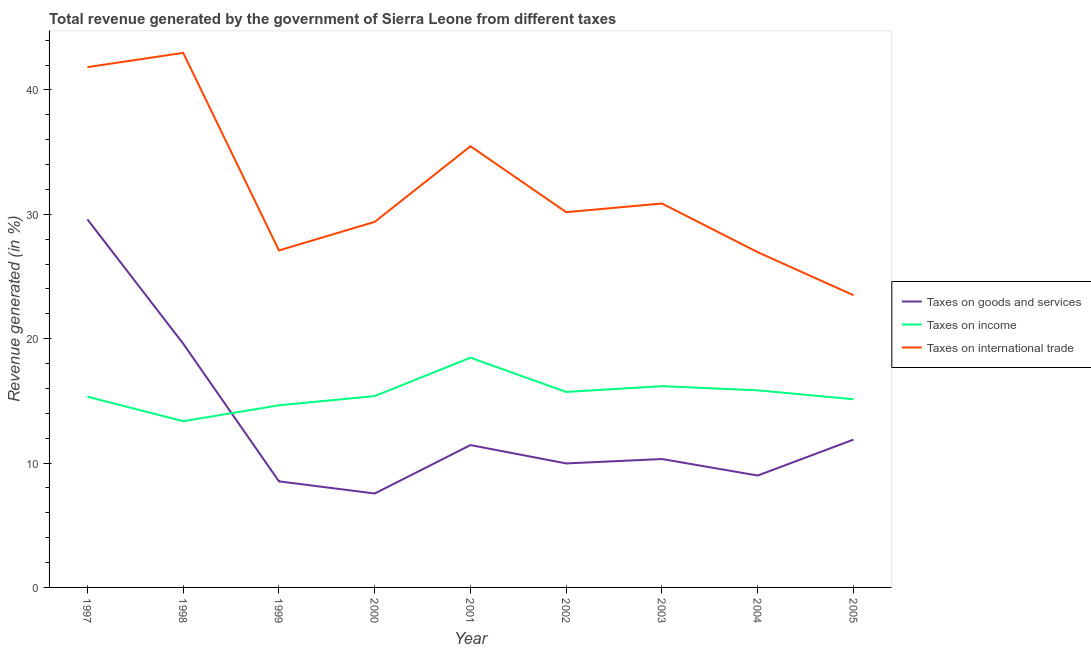Is the number of lines equal to the number of legend labels?
Keep it short and to the point. Yes. What is the percentage of revenue generated by tax on international trade in 2004?
Ensure brevity in your answer.  26.96. Across all years, what is the maximum percentage of revenue generated by taxes on goods and services?
Provide a short and direct response. 29.59. Across all years, what is the minimum percentage of revenue generated by taxes on income?
Offer a very short reply. 13.37. In which year was the percentage of revenue generated by tax on international trade maximum?
Provide a short and direct response. 1998. What is the total percentage of revenue generated by tax on international trade in the graph?
Offer a terse response. 288.28. What is the difference between the percentage of revenue generated by tax on international trade in 2000 and that in 2001?
Provide a succinct answer. -6.08. What is the difference between the percentage of revenue generated by taxes on income in 1997 and the percentage of revenue generated by tax on international trade in 2000?
Provide a short and direct response. -14.06. What is the average percentage of revenue generated by tax on international trade per year?
Keep it short and to the point. 32.03. In the year 2003, what is the difference between the percentage of revenue generated by tax on international trade and percentage of revenue generated by taxes on goods and services?
Provide a succinct answer. 20.55. What is the ratio of the percentage of revenue generated by taxes on goods and services in 2000 to that in 2003?
Provide a short and direct response. 0.73. What is the difference between the highest and the second highest percentage of revenue generated by tax on international trade?
Provide a succinct answer. 1.15. What is the difference between the highest and the lowest percentage of revenue generated by taxes on income?
Provide a short and direct response. 5.1. In how many years, is the percentage of revenue generated by taxes on goods and services greater than the average percentage of revenue generated by taxes on goods and services taken over all years?
Your answer should be compact. 2. Is the percentage of revenue generated by taxes on goods and services strictly less than the percentage of revenue generated by tax on international trade over the years?
Your response must be concise. Yes. How many lines are there?
Your answer should be compact. 3. How many years are there in the graph?
Your response must be concise. 9. Does the graph contain any zero values?
Keep it short and to the point. No. Where does the legend appear in the graph?
Ensure brevity in your answer.  Center right. What is the title of the graph?
Keep it short and to the point. Total revenue generated by the government of Sierra Leone from different taxes. Does "Ages 15-20" appear as one of the legend labels in the graph?
Provide a succinct answer. No. What is the label or title of the Y-axis?
Keep it short and to the point. Revenue generated (in %). What is the Revenue generated (in %) of Taxes on goods and services in 1997?
Your answer should be very brief. 29.59. What is the Revenue generated (in %) in Taxes on income in 1997?
Give a very brief answer. 15.34. What is the Revenue generated (in %) of Taxes on international trade in 1997?
Give a very brief answer. 41.84. What is the Revenue generated (in %) in Taxes on goods and services in 1998?
Provide a succinct answer. 19.6. What is the Revenue generated (in %) of Taxes on income in 1998?
Provide a succinct answer. 13.37. What is the Revenue generated (in %) in Taxes on international trade in 1998?
Provide a short and direct response. 42.99. What is the Revenue generated (in %) in Taxes on goods and services in 1999?
Provide a short and direct response. 8.53. What is the Revenue generated (in %) of Taxes on income in 1999?
Your answer should be compact. 14.65. What is the Revenue generated (in %) of Taxes on international trade in 1999?
Keep it short and to the point. 27.1. What is the Revenue generated (in %) in Taxes on goods and services in 2000?
Offer a very short reply. 7.55. What is the Revenue generated (in %) in Taxes on income in 2000?
Your response must be concise. 15.39. What is the Revenue generated (in %) in Taxes on international trade in 2000?
Give a very brief answer. 29.39. What is the Revenue generated (in %) in Taxes on goods and services in 2001?
Make the answer very short. 11.45. What is the Revenue generated (in %) in Taxes on income in 2001?
Your response must be concise. 18.47. What is the Revenue generated (in %) of Taxes on international trade in 2001?
Offer a terse response. 35.48. What is the Revenue generated (in %) of Taxes on goods and services in 2002?
Make the answer very short. 9.97. What is the Revenue generated (in %) in Taxes on income in 2002?
Offer a terse response. 15.72. What is the Revenue generated (in %) in Taxes on international trade in 2002?
Give a very brief answer. 30.17. What is the Revenue generated (in %) of Taxes on goods and services in 2003?
Keep it short and to the point. 10.32. What is the Revenue generated (in %) in Taxes on income in 2003?
Offer a terse response. 16.18. What is the Revenue generated (in %) in Taxes on international trade in 2003?
Offer a very short reply. 30.87. What is the Revenue generated (in %) of Taxes on goods and services in 2004?
Provide a short and direct response. 9. What is the Revenue generated (in %) of Taxes on income in 2004?
Your response must be concise. 15.85. What is the Revenue generated (in %) of Taxes on international trade in 2004?
Your response must be concise. 26.96. What is the Revenue generated (in %) in Taxes on goods and services in 2005?
Offer a terse response. 11.89. What is the Revenue generated (in %) in Taxes on income in 2005?
Give a very brief answer. 15.13. What is the Revenue generated (in %) of Taxes on international trade in 2005?
Offer a very short reply. 23.5. Across all years, what is the maximum Revenue generated (in %) in Taxes on goods and services?
Make the answer very short. 29.59. Across all years, what is the maximum Revenue generated (in %) of Taxes on income?
Your response must be concise. 18.47. Across all years, what is the maximum Revenue generated (in %) in Taxes on international trade?
Your answer should be compact. 42.99. Across all years, what is the minimum Revenue generated (in %) in Taxes on goods and services?
Ensure brevity in your answer.  7.55. Across all years, what is the minimum Revenue generated (in %) of Taxes on income?
Provide a succinct answer. 13.37. Across all years, what is the minimum Revenue generated (in %) in Taxes on international trade?
Make the answer very short. 23.5. What is the total Revenue generated (in %) in Taxes on goods and services in the graph?
Provide a succinct answer. 117.9. What is the total Revenue generated (in %) in Taxes on income in the graph?
Your answer should be very brief. 140.09. What is the total Revenue generated (in %) of Taxes on international trade in the graph?
Offer a terse response. 288.28. What is the difference between the Revenue generated (in %) of Taxes on goods and services in 1997 and that in 1998?
Your answer should be very brief. 9.99. What is the difference between the Revenue generated (in %) of Taxes on income in 1997 and that in 1998?
Offer a terse response. 1.97. What is the difference between the Revenue generated (in %) of Taxes on international trade in 1997 and that in 1998?
Provide a succinct answer. -1.15. What is the difference between the Revenue generated (in %) in Taxes on goods and services in 1997 and that in 1999?
Give a very brief answer. 21.07. What is the difference between the Revenue generated (in %) in Taxes on income in 1997 and that in 1999?
Provide a short and direct response. 0.69. What is the difference between the Revenue generated (in %) in Taxes on international trade in 1997 and that in 1999?
Your answer should be compact. 14.74. What is the difference between the Revenue generated (in %) in Taxes on goods and services in 1997 and that in 2000?
Make the answer very short. 22.04. What is the difference between the Revenue generated (in %) in Taxes on income in 1997 and that in 2000?
Your answer should be very brief. -0.05. What is the difference between the Revenue generated (in %) of Taxes on international trade in 1997 and that in 2000?
Offer a terse response. 12.44. What is the difference between the Revenue generated (in %) in Taxes on goods and services in 1997 and that in 2001?
Offer a very short reply. 18.15. What is the difference between the Revenue generated (in %) in Taxes on income in 1997 and that in 2001?
Your answer should be very brief. -3.13. What is the difference between the Revenue generated (in %) of Taxes on international trade in 1997 and that in 2001?
Keep it short and to the point. 6.36. What is the difference between the Revenue generated (in %) of Taxes on goods and services in 1997 and that in 2002?
Provide a succinct answer. 19.62. What is the difference between the Revenue generated (in %) in Taxes on income in 1997 and that in 2002?
Your response must be concise. -0.38. What is the difference between the Revenue generated (in %) of Taxes on international trade in 1997 and that in 2002?
Provide a succinct answer. 11.66. What is the difference between the Revenue generated (in %) in Taxes on goods and services in 1997 and that in 2003?
Provide a short and direct response. 19.27. What is the difference between the Revenue generated (in %) in Taxes on income in 1997 and that in 2003?
Your answer should be very brief. -0.85. What is the difference between the Revenue generated (in %) in Taxes on international trade in 1997 and that in 2003?
Your answer should be very brief. 10.97. What is the difference between the Revenue generated (in %) in Taxes on goods and services in 1997 and that in 2004?
Give a very brief answer. 20.6. What is the difference between the Revenue generated (in %) in Taxes on income in 1997 and that in 2004?
Provide a succinct answer. -0.51. What is the difference between the Revenue generated (in %) in Taxes on international trade in 1997 and that in 2004?
Make the answer very short. 14.88. What is the difference between the Revenue generated (in %) of Taxes on goods and services in 1997 and that in 2005?
Provide a short and direct response. 17.71. What is the difference between the Revenue generated (in %) of Taxes on income in 1997 and that in 2005?
Your response must be concise. 0.2. What is the difference between the Revenue generated (in %) of Taxes on international trade in 1997 and that in 2005?
Provide a succinct answer. 18.34. What is the difference between the Revenue generated (in %) in Taxes on goods and services in 1998 and that in 1999?
Offer a very short reply. 11.07. What is the difference between the Revenue generated (in %) of Taxes on income in 1998 and that in 1999?
Offer a very short reply. -1.28. What is the difference between the Revenue generated (in %) in Taxes on international trade in 1998 and that in 1999?
Your answer should be very brief. 15.89. What is the difference between the Revenue generated (in %) in Taxes on goods and services in 1998 and that in 2000?
Your response must be concise. 12.05. What is the difference between the Revenue generated (in %) in Taxes on income in 1998 and that in 2000?
Provide a short and direct response. -2.02. What is the difference between the Revenue generated (in %) in Taxes on international trade in 1998 and that in 2000?
Offer a very short reply. 13.59. What is the difference between the Revenue generated (in %) of Taxes on goods and services in 1998 and that in 2001?
Provide a short and direct response. 8.16. What is the difference between the Revenue generated (in %) in Taxes on income in 1998 and that in 2001?
Your response must be concise. -5.1. What is the difference between the Revenue generated (in %) in Taxes on international trade in 1998 and that in 2001?
Keep it short and to the point. 7.51. What is the difference between the Revenue generated (in %) of Taxes on goods and services in 1998 and that in 2002?
Ensure brevity in your answer.  9.63. What is the difference between the Revenue generated (in %) in Taxes on income in 1998 and that in 2002?
Provide a short and direct response. -2.35. What is the difference between the Revenue generated (in %) of Taxes on international trade in 1998 and that in 2002?
Give a very brief answer. 12.81. What is the difference between the Revenue generated (in %) of Taxes on goods and services in 1998 and that in 2003?
Provide a succinct answer. 9.28. What is the difference between the Revenue generated (in %) of Taxes on income in 1998 and that in 2003?
Ensure brevity in your answer.  -2.82. What is the difference between the Revenue generated (in %) in Taxes on international trade in 1998 and that in 2003?
Provide a succinct answer. 12.11. What is the difference between the Revenue generated (in %) of Taxes on goods and services in 1998 and that in 2004?
Provide a short and direct response. 10.6. What is the difference between the Revenue generated (in %) of Taxes on income in 1998 and that in 2004?
Keep it short and to the point. -2.48. What is the difference between the Revenue generated (in %) of Taxes on international trade in 1998 and that in 2004?
Your answer should be compact. 16.03. What is the difference between the Revenue generated (in %) in Taxes on goods and services in 1998 and that in 2005?
Ensure brevity in your answer.  7.72. What is the difference between the Revenue generated (in %) in Taxes on income in 1998 and that in 2005?
Your answer should be very brief. -1.76. What is the difference between the Revenue generated (in %) in Taxes on international trade in 1998 and that in 2005?
Ensure brevity in your answer.  19.49. What is the difference between the Revenue generated (in %) of Taxes on goods and services in 1999 and that in 2000?
Keep it short and to the point. 0.98. What is the difference between the Revenue generated (in %) of Taxes on income in 1999 and that in 2000?
Your response must be concise. -0.74. What is the difference between the Revenue generated (in %) in Taxes on international trade in 1999 and that in 2000?
Offer a terse response. -2.3. What is the difference between the Revenue generated (in %) in Taxes on goods and services in 1999 and that in 2001?
Offer a very short reply. -2.92. What is the difference between the Revenue generated (in %) of Taxes on income in 1999 and that in 2001?
Ensure brevity in your answer.  -3.83. What is the difference between the Revenue generated (in %) in Taxes on international trade in 1999 and that in 2001?
Offer a terse response. -8.38. What is the difference between the Revenue generated (in %) of Taxes on goods and services in 1999 and that in 2002?
Provide a short and direct response. -1.44. What is the difference between the Revenue generated (in %) in Taxes on income in 1999 and that in 2002?
Provide a short and direct response. -1.07. What is the difference between the Revenue generated (in %) of Taxes on international trade in 1999 and that in 2002?
Offer a very short reply. -3.08. What is the difference between the Revenue generated (in %) in Taxes on goods and services in 1999 and that in 2003?
Offer a very short reply. -1.79. What is the difference between the Revenue generated (in %) in Taxes on income in 1999 and that in 2003?
Your answer should be very brief. -1.54. What is the difference between the Revenue generated (in %) of Taxes on international trade in 1999 and that in 2003?
Your answer should be compact. -3.77. What is the difference between the Revenue generated (in %) in Taxes on goods and services in 1999 and that in 2004?
Make the answer very short. -0.47. What is the difference between the Revenue generated (in %) of Taxes on income in 1999 and that in 2004?
Provide a succinct answer. -1.2. What is the difference between the Revenue generated (in %) in Taxes on international trade in 1999 and that in 2004?
Provide a short and direct response. 0.14. What is the difference between the Revenue generated (in %) of Taxes on goods and services in 1999 and that in 2005?
Provide a short and direct response. -3.36. What is the difference between the Revenue generated (in %) in Taxes on income in 1999 and that in 2005?
Offer a very short reply. -0.49. What is the difference between the Revenue generated (in %) of Taxes on international trade in 1999 and that in 2005?
Ensure brevity in your answer.  3.6. What is the difference between the Revenue generated (in %) in Taxes on goods and services in 2000 and that in 2001?
Give a very brief answer. -3.89. What is the difference between the Revenue generated (in %) in Taxes on income in 2000 and that in 2001?
Offer a terse response. -3.08. What is the difference between the Revenue generated (in %) in Taxes on international trade in 2000 and that in 2001?
Keep it short and to the point. -6.08. What is the difference between the Revenue generated (in %) of Taxes on goods and services in 2000 and that in 2002?
Offer a terse response. -2.42. What is the difference between the Revenue generated (in %) in Taxes on income in 2000 and that in 2002?
Keep it short and to the point. -0.33. What is the difference between the Revenue generated (in %) in Taxes on international trade in 2000 and that in 2002?
Provide a short and direct response. -0.78. What is the difference between the Revenue generated (in %) in Taxes on goods and services in 2000 and that in 2003?
Give a very brief answer. -2.77. What is the difference between the Revenue generated (in %) of Taxes on income in 2000 and that in 2003?
Offer a terse response. -0.8. What is the difference between the Revenue generated (in %) in Taxes on international trade in 2000 and that in 2003?
Provide a succinct answer. -1.48. What is the difference between the Revenue generated (in %) in Taxes on goods and services in 2000 and that in 2004?
Offer a very short reply. -1.44. What is the difference between the Revenue generated (in %) of Taxes on income in 2000 and that in 2004?
Provide a succinct answer. -0.46. What is the difference between the Revenue generated (in %) in Taxes on international trade in 2000 and that in 2004?
Give a very brief answer. 2.44. What is the difference between the Revenue generated (in %) in Taxes on goods and services in 2000 and that in 2005?
Provide a short and direct response. -4.33. What is the difference between the Revenue generated (in %) of Taxes on income in 2000 and that in 2005?
Offer a very short reply. 0.26. What is the difference between the Revenue generated (in %) in Taxes on international trade in 2000 and that in 2005?
Your response must be concise. 5.9. What is the difference between the Revenue generated (in %) of Taxes on goods and services in 2001 and that in 2002?
Provide a short and direct response. 1.48. What is the difference between the Revenue generated (in %) of Taxes on income in 2001 and that in 2002?
Keep it short and to the point. 2.75. What is the difference between the Revenue generated (in %) in Taxes on international trade in 2001 and that in 2002?
Your answer should be very brief. 5.3. What is the difference between the Revenue generated (in %) of Taxes on goods and services in 2001 and that in 2003?
Provide a succinct answer. 1.12. What is the difference between the Revenue generated (in %) in Taxes on income in 2001 and that in 2003?
Keep it short and to the point. 2.29. What is the difference between the Revenue generated (in %) of Taxes on international trade in 2001 and that in 2003?
Your answer should be very brief. 4.61. What is the difference between the Revenue generated (in %) of Taxes on goods and services in 2001 and that in 2004?
Provide a succinct answer. 2.45. What is the difference between the Revenue generated (in %) of Taxes on income in 2001 and that in 2004?
Make the answer very short. 2.62. What is the difference between the Revenue generated (in %) in Taxes on international trade in 2001 and that in 2004?
Provide a short and direct response. 8.52. What is the difference between the Revenue generated (in %) in Taxes on goods and services in 2001 and that in 2005?
Provide a succinct answer. -0.44. What is the difference between the Revenue generated (in %) in Taxes on income in 2001 and that in 2005?
Your response must be concise. 3.34. What is the difference between the Revenue generated (in %) of Taxes on international trade in 2001 and that in 2005?
Provide a succinct answer. 11.98. What is the difference between the Revenue generated (in %) of Taxes on goods and services in 2002 and that in 2003?
Your answer should be very brief. -0.35. What is the difference between the Revenue generated (in %) in Taxes on income in 2002 and that in 2003?
Provide a succinct answer. -0.46. What is the difference between the Revenue generated (in %) in Taxes on international trade in 2002 and that in 2003?
Your answer should be very brief. -0.7. What is the difference between the Revenue generated (in %) of Taxes on goods and services in 2002 and that in 2004?
Offer a terse response. 0.97. What is the difference between the Revenue generated (in %) of Taxes on income in 2002 and that in 2004?
Keep it short and to the point. -0.13. What is the difference between the Revenue generated (in %) of Taxes on international trade in 2002 and that in 2004?
Your answer should be very brief. 3.22. What is the difference between the Revenue generated (in %) of Taxes on goods and services in 2002 and that in 2005?
Keep it short and to the point. -1.92. What is the difference between the Revenue generated (in %) in Taxes on income in 2002 and that in 2005?
Your response must be concise. 0.59. What is the difference between the Revenue generated (in %) in Taxes on international trade in 2002 and that in 2005?
Provide a short and direct response. 6.68. What is the difference between the Revenue generated (in %) in Taxes on goods and services in 2003 and that in 2004?
Offer a terse response. 1.33. What is the difference between the Revenue generated (in %) in Taxes on income in 2003 and that in 2004?
Make the answer very short. 0.34. What is the difference between the Revenue generated (in %) in Taxes on international trade in 2003 and that in 2004?
Your answer should be compact. 3.92. What is the difference between the Revenue generated (in %) in Taxes on goods and services in 2003 and that in 2005?
Your answer should be compact. -1.56. What is the difference between the Revenue generated (in %) of Taxes on income in 2003 and that in 2005?
Provide a short and direct response. 1.05. What is the difference between the Revenue generated (in %) of Taxes on international trade in 2003 and that in 2005?
Your response must be concise. 7.38. What is the difference between the Revenue generated (in %) of Taxes on goods and services in 2004 and that in 2005?
Give a very brief answer. -2.89. What is the difference between the Revenue generated (in %) in Taxes on income in 2004 and that in 2005?
Your answer should be very brief. 0.72. What is the difference between the Revenue generated (in %) in Taxes on international trade in 2004 and that in 2005?
Your answer should be very brief. 3.46. What is the difference between the Revenue generated (in %) in Taxes on goods and services in 1997 and the Revenue generated (in %) in Taxes on income in 1998?
Keep it short and to the point. 16.23. What is the difference between the Revenue generated (in %) in Taxes on goods and services in 1997 and the Revenue generated (in %) in Taxes on international trade in 1998?
Ensure brevity in your answer.  -13.39. What is the difference between the Revenue generated (in %) of Taxes on income in 1997 and the Revenue generated (in %) of Taxes on international trade in 1998?
Your response must be concise. -27.65. What is the difference between the Revenue generated (in %) in Taxes on goods and services in 1997 and the Revenue generated (in %) in Taxes on income in 1999?
Provide a succinct answer. 14.95. What is the difference between the Revenue generated (in %) in Taxes on goods and services in 1997 and the Revenue generated (in %) in Taxes on international trade in 1999?
Provide a succinct answer. 2.5. What is the difference between the Revenue generated (in %) of Taxes on income in 1997 and the Revenue generated (in %) of Taxes on international trade in 1999?
Your answer should be very brief. -11.76. What is the difference between the Revenue generated (in %) of Taxes on goods and services in 1997 and the Revenue generated (in %) of Taxes on income in 2000?
Keep it short and to the point. 14.21. What is the difference between the Revenue generated (in %) in Taxes on goods and services in 1997 and the Revenue generated (in %) in Taxes on international trade in 2000?
Give a very brief answer. 0.2. What is the difference between the Revenue generated (in %) of Taxes on income in 1997 and the Revenue generated (in %) of Taxes on international trade in 2000?
Give a very brief answer. -14.06. What is the difference between the Revenue generated (in %) of Taxes on goods and services in 1997 and the Revenue generated (in %) of Taxes on income in 2001?
Your response must be concise. 11.12. What is the difference between the Revenue generated (in %) of Taxes on goods and services in 1997 and the Revenue generated (in %) of Taxes on international trade in 2001?
Make the answer very short. -5.88. What is the difference between the Revenue generated (in %) in Taxes on income in 1997 and the Revenue generated (in %) in Taxes on international trade in 2001?
Your answer should be compact. -20.14. What is the difference between the Revenue generated (in %) of Taxes on goods and services in 1997 and the Revenue generated (in %) of Taxes on income in 2002?
Your answer should be very brief. 13.88. What is the difference between the Revenue generated (in %) of Taxes on goods and services in 1997 and the Revenue generated (in %) of Taxes on international trade in 2002?
Provide a short and direct response. -0.58. What is the difference between the Revenue generated (in %) of Taxes on income in 1997 and the Revenue generated (in %) of Taxes on international trade in 2002?
Provide a succinct answer. -14.84. What is the difference between the Revenue generated (in %) in Taxes on goods and services in 1997 and the Revenue generated (in %) in Taxes on income in 2003?
Give a very brief answer. 13.41. What is the difference between the Revenue generated (in %) of Taxes on goods and services in 1997 and the Revenue generated (in %) of Taxes on international trade in 2003?
Give a very brief answer. -1.28. What is the difference between the Revenue generated (in %) of Taxes on income in 1997 and the Revenue generated (in %) of Taxes on international trade in 2003?
Provide a succinct answer. -15.53. What is the difference between the Revenue generated (in %) of Taxes on goods and services in 1997 and the Revenue generated (in %) of Taxes on income in 2004?
Your answer should be very brief. 13.75. What is the difference between the Revenue generated (in %) in Taxes on goods and services in 1997 and the Revenue generated (in %) in Taxes on international trade in 2004?
Your response must be concise. 2.64. What is the difference between the Revenue generated (in %) in Taxes on income in 1997 and the Revenue generated (in %) in Taxes on international trade in 2004?
Provide a short and direct response. -11.62. What is the difference between the Revenue generated (in %) in Taxes on goods and services in 1997 and the Revenue generated (in %) in Taxes on income in 2005?
Your answer should be compact. 14.46. What is the difference between the Revenue generated (in %) in Taxes on goods and services in 1997 and the Revenue generated (in %) in Taxes on international trade in 2005?
Offer a terse response. 6.1. What is the difference between the Revenue generated (in %) of Taxes on income in 1997 and the Revenue generated (in %) of Taxes on international trade in 2005?
Keep it short and to the point. -8.16. What is the difference between the Revenue generated (in %) in Taxes on goods and services in 1998 and the Revenue generated (in %) in Taxes on income in 1999?
Your answer should be very brief. 4.96. What is the difference between the Revenue generated (in %) in Taxes on goods and services in 1998 and the Revenue generated (in %) in Taxes on international trade in 1999?
Keep it short and to the point. -7.5. What is the difference between the Revenue generated (in %) of Taxes on income in 1998 and the Revenue generated (in %) of Taxes on international trade in 1999?
Ensure brevity in your answer.  -13.73. What is the difference between the Revenue generated (in %) in Taxes on goods and services in 1998 and the Revenue generated (in %) in Taxes on income in 2000?
Give a very brief answer. 4.21. What is the difference between the Revenue generated (in %) in Taxes on goods and services in 1998 and the Revenue generated (in %) in Taxes on international trade in 2000?
Your response must be concise. -9.79. What is the difference between the Revenue generated (in %) of Taxes on income in 1998 and the Revenue generated (in %) of Taxes on international trade in 2000?
Ensure brevity in your answer.  -16.03. What is the difference between the Revenue generated (in %) in Taxes on goods and services in 1998 and the Revenue generated (in %) in Taxes on income in 2001?
Provide a short and direct response. 1.13. What is the difference between the Revenue generated (in %) in Taxes on goods and services in 1998 and the Revenue generated (in %) in Taxes on international trade in 2001?
Ensure brevity in your answer.  -15.87. What is the difference between the Revenue generated (in %) of Taxes on income in 1998 and the Revenue generated (in %) of Taxes on international trade in 2001?
Ensure brevity in your answer.  -22.11. What is the difference between the Revenue generated (in %) in Taxes on goods and services in 1998 and the Revenue generated (in %) in Taxes on income in 2002?
Provide a succinct answer. 3.88. What is the difference between the Revenue generated (in %) of Taxes on goods and services in 1998 and the Revenue generated (in %) of Taxes on international trade in 2002?
Offer a terse response. -10.57. What is the difference between the Revenue generated (in %) of Taxes on income in 1998 and the Revenue generated (in %) of Taxes on international trade in 2002?
Offer a very short reply. -16.81. What is the difference between the Revenue generated (in %) of Taxes on goods and services in 1998 and the Revenue generated (in %) of Taxes on income in 2003?
Keep it short and to the point. 3.42. What is the difference between the Revenue generated (in %) in Taxes on goods and services in 1998 and the Revenue generated (in %) in Taxes on international trade in 2003?
Offer a very short reply. -11.27. What is the difference between the Revenue generated (in %) of Taxes on income in 1998 and the Revenue generated (in %) of Taxes on international trade in 2003?
Your response must be concise. -17.5. What is the difference between the Revenue generated (in %) in Taxes on goods and services in 1998 and the Revenue generated (in %) in Taxes on income in 2004?
Your response must be concise. 3.75. What is the difference between the Revenue generated (in %) of Taxes on goods and services in 1998 and the Revenue generated (in %) of Taxes on international trade in 2004?
Ensure brevity in your answer.  -7.35. What is the difference between the Revenue generated (in %) of Taxes on income in 1998 and the Revenue generated (in %) of Taxes on international trade in 2004?
Your answer should be very brief. -13.59. What is the difference between the Revenue generated (in %) in Taxes on goods and services in 1998 and the Revenue generated (in %) in Taxes on income in 2005?
Make the answer very short. 4.47. What is the difference between the Revenue generated (in %) in Taxes on goods and services in 1998 and the Revenue generated (in %) in Taxes on international trade in 2005?
Your answer should be very brief. -3.89. What is the difference between the Revenue generated (in %) of Taxes on income in 1998 and the Revenue generated (in %) of Taxes on international trade in 2005?
Provide a succinct answer. -10.13. What is the difference between the Revenue generated (in %) in Taxes on goods and services in 1999 and the Revenue generated (in %) in Taxes on income in 2000?
Ensure brevity in your answer.  -6.86. What is the difference between the Revenue generated (in %) in Taxes on goods and services in 1999 and the Revenue generated (in %) in Taxes on international trade in 2000?
Provide a short and direct response. -20.86. What is the difference between the Revenue generated (in %) in Taxes on income in 1999 and the Revenue generated (in %) in Taxes on international trade in 2000?
Your answer should be compact. -14.75. What is the difference between the Revenue generated (in %) of Taxes on goods and services in 1999 and the Revenue generated (in %) of Taxes on income in 2001?
Your answer should be compact. -9.94. What is the difference between the Revenue generated (in %) of Taxes on goods and services in 1999 and the Revenue generated (in %) of Taxes on international trade in 2001?
Make the answer very short. -26.95. What is the difference between the Revenue generated (in %) of Taxes on income in 1999 and the Revenue generated (in %) of Taxes on international trade in 2001?
Give a very brief answer. -20.83. What is the difference between the Revenue generated (in %) of Taxes on goods and services in 1999 and the Revenue generated (in %) of Taxes on income in 2002?
Give a very brief answer. -7.19. What is the difference between the Revenue generated (in %) of Taxes on goods and services in 1999 and the Revenue generated (in %) of Taxes on international trade in 2002?
Your answer should be very brief. -21.64. What is the difference between the Revenue generated (in %) in Taxes on income in 1999 and the Revenue generated (in %) in Taxes on international trade in 2002?
Give a very brief answer. -15.53. What is the difference between the Revenue generated (in %) of Taxes on goods and services in 1999 and the Revenue generated (in %) of Taxes on income in 2003?
Offer a very short reply. -7.66. What is the difference between the Revenue generated (in %) in Taxes on goods and services in 1999 and the Revenue generated (in %) in Taxes on international trade in 2003?
Your response must be concise. -22.34. What is the difference between the Revenue generated (in %) of Taxes on income in 1999 and the Revenue generated (in %) of Taxes on international trade in 2003?
Your answer should be compact. -16.23. What is the difference between the Revenue generated (in %) in Taxes on goods and services in 1999 and the Revenue generated (in %) in Taxes on income in 2004?
Provide a succinct answer. -7.32. What is the difference between the Revenue generated (in %) of Taxes on goods and services in 1999 and the Revenue generated (in %) of Taxes on international trade in 2004?
Give a very brief answer. -18.43. What is the difference between the Revenue generated (in %) in Taxes on income in 1999 and the Revenue generated (in %) in Taxes on international trade in 2004?
Keep it short and to the point. -12.31. What is the difference between the Revenue generated (in %) of Taxes on goods and services in 1999 and the Revenue generated (in %) of Taxes on income in 2005?
Your answer should be compact. -6.6. What is the difference between the Revenue generated (in %) in Taxes on goods and services in 1999 and the Revenue generated (in %) in Taxes on international trade in 2005?
Provide a short and direct response. -14.97. What is the difference between the Revenue generated (in %) in Taxes on income in 1999 and the Revenue generated (in %) in Taxes on international trade in 2005?
Keep it short and to the point. -8.85. What is the difference between the Revenue generated (in %) in Taxes on goods and services in 2000 and the Revenue generated (in %) in Taxes on income in 2001?
Provide a succinct answer. -10.92. What is the difference between the Revenue generated (in %) in Taxes on goods and services in 2000 and the Revenue generated (in %) in Taxes on international trade in 2001?
Your response must be concise. -27.92. What is the difference between the Revenue generated (in %) of Taxes on income in 2000 and the Revenue generated (in %) of Taxes on international trade in 2001?
Ensure brevity in your answer.  -20.09. What is the difference between the Revenue generated (in %) of Taxes on goods and services in 2000 and the Revenue generated (in %) of Taxes on income in 2002?
Make the answer very short. -8.17. What is the difference between the Revenue generated (in %) in Taxes on goods and services in 2000 and the Revenue generated (in %) in Taxes on international trade in 2002?
Give a very brief answer. -22.62. What is the difference between the Revenue generated (in %) in Taxes on income in 2000 and the Revenue generated (in %) in Taxes on international trade in 2002?
Ensure brevity in your answer.  -14.79. What is the difference between the Revenue generated (in %) of Taxes on goods and services in 2000 and the Revenue generated (in %) of Taxes on income in 2003?
Your response must be concise. -8.63. What is the difference between the Revenue generated (in %) in Taxes on goods and services in 2000 and the Revenue generated (in %) in Taxes on international trade in 2003?
Provide a short and direct response. -23.32. What is the difference between the Revenue generated (in %) in Taxes on income in 2000 and the Revenue generated (in %) in Taxes on international trade in 2003?
Provide a succinct answer. -15.48. What is the difference between the Revenue generated (in %) in Taxes on goods and services in 2000 and the Revenue generated (in %) in Taxes on income in 2004?
Ensure brevity in your answer.  -8.3. What is the difference between the Revenue generated (in %) in Taxes on goods and services in 2000 and the Revenue generated (in %) in Taxes on international trade in 2004?
Offer a terse response. -19.4. What is the difference between the Revenue generated (in %) in Taxes on income in 2000 and the Revenue generated (in %) in Taxes on international trade in 2004?
Provide a short and direct response. -11.57. What is the difference between the Revenue generated (in %) of Taxes on goods and services in 2000 and the Revenue generated (in %) of Taxes on income in 2005?
Provide a short and direct response. -7.58. What is the difference between the Revenue generated (in %) of Taxes on goods and services in 2000 and the Revenue generated (in %) of Taxes on international trade in 2005?
Ensure brevity in your answer.  -15.94. What is the difference between the Revenue generated (in %) in Taxes on income in 2000 and the Revenue generated (in %) in Taxes on international trade in 2005?
Make the answer very short. -8.11. What is the difference between the Revenue generated (in %) in Taxes on goods and services in 2001 and the Revenue generated (in %) in Taxes on income in 2002?
Provide a short and direct response. -4.27. What is the difference between the Revenue generated (in %) in Taxes on goods and services in 2001 and the Revenue generated (in %) in Taxes on international trade in 2002?
Offer a terse response. -18.73. What is the difference between the Revenue generated (in %) in Taxes on income in 2001 and the Revenue generated (in %) in Taxes on international trade in 2002?
Keep it short and to the point. -11.7. What is the difference between the Revenue generated (in %) in Taxes on goods and services in 2001 and the Revenue generated (in %) in Taxes on income in 2003?
Offer a very short reply. -4.74. What is the difference between the Revenue generated (in %) in Taxes on goods and services in 2001 and the Revenue generated (in %) in Taxes on international trade in 2003?
Offer a very short reply. -19.42. What is the difference between the Revenue generated (in %) in Taxes on income in 2001 and the Revenue generated (in %) in Taxes on international trade in 2003?
Your response must be concise. -12.4. What is the difference between the Revenue generated (in %) in Taxes on goods and services in 2001 and the Revenue generated (in %) in Taxes on income in 2004?
Give a very brief answer. -4.4. What is the difference between the Revenue generated (in %) in Taxes on goods and services in 2001 and the Revenue generated (in %) in Taxes on international trade in 2004?
Give a very brief answer. -15.51. What is the difference between the Revenue generated (in %) of Taxes on income in 2001 and the Revenue generated (in %) of Taxes on international trade in 2004?
Offer a terse response. -8.48. What is the difference between the Revenue generated (in %) in Taxes on goods and services in 2001 and the Revenue generated (in %) in Taxes on income in 2005?
Make the answer very short. -3.69. What is the difference between the Revenue generated (in %) in Taxes on goods and services in 2001 and the Revenue generated (in %) in Taxes on international trade in 2005?
Make the answer very short. -12.05. What is the difference between the Revenue generated (in %) in Taxes on income in 2001 and the Revenue generated (in %) in Taxes on international trade in 2005?
Your response must be concise. -5.03. What is the difference between the Revenue generated (in %) of Taxes on goods and services in 2002 and the Revenue generated (in %) of Taxes on income in 2003?
Ensure brevity in your answer.  -6.21. What is the difference between the Revenue generated (in %) of Taxes on goods and services in 2002 and the Revenue generated (in %) of Taxes on international trade in 2003?
Provide a short and direct response. -20.9. What is the difference between the Revenue generated (in %) of Taxes on income in 2002 and the Revenue generated (in %) of Taxes on international trade in 2003?
Ensure brevity in your answer.  -15.15. What is the difference between the Revenue generated (in %) of Taxes on goods and services in 2002 and the Revenue generated (in %) of Taxes on income in 2004?
Your answer should be very brief. -5.88. What is the difference between the Revenue generated (in %) of Taxes on goods and services in 2002 and the Revenue generated (in %) of Taxes on international trade in 2004?
Give a very brief answer. -16.98. What is the difference between the Revenue generated (in %) in Taxes on income in 2002 and the Revenue generated (in %) in Taxes on international trade in 2004?
Offer a very short reply. -11.24. What is the difference between the Revenue generated (in %) of Taxes on goods and services in 2002 and the Revenue generated (in %) of Taxes on income in 2005?
Provide a short and direct response. -5.16. What is the difference between the Revenue generated (in %) of Taxes on goods and services in 2002 and the Revenue generated (in %) of Taxes on international trade in 2005?
Offer a terse response. -13.53. What is the difference between the Revenue generated (in %) of Taxes on income in 2002 and the Revenue generated (in %) of Taxes on international trade in 2005?
Keep it short and to the point. -7.78. What is the difference between the Revenue generated (in %) of Taxes on goods and services in 2003 and the Revenue generated (in %) of Taxes on income in 2004?
Provide a short and direct response. -5.52. What is the difference between the Revenue generated (in %) of Taxes on goods and services in 2003 and the Revenue generated (in %) of Taxes on international trade in 2004?
Offer a very short reply. -16.63. What is the difference between the Revenue generated (in %) in Taxes on income in 2003 and the Revenue generated (in %) in Taxes on international trade in 2004?
Offer a very short reply. -10.77. What is the difference between the Revenue generated (in %) of Taxes on goods and services in 2003 and the Revenue generated (in %) of Taxes on income in 2005?
Give a very brief answer. -4.81. What is the difference between the Revenue generated (in %) of Taxes on goods and services in 2003 and the Revenue generated (in %) of Taxes on international trade in 2005?
Ensure brevity in your answer.  -13.17. What is the difference between the Revenue generated (in %) in Taxes on income in 2003 and the Revenue generated (in %) in Taxes on international trade in 2005?
Your response must be concise. -7.31. What is the difference between the Revenue generated (in %) in Taxes on goods and services in 2004 and the Revenue generated (in %) in Taxes on income in 2005?
Give a very brief answer. -6.13. What is the difference between the Revenue generated (in %) in Taxes on goods and services in 2004 and the Revenue generated (in %) in Taxes on international trade in 2005?
Your answer should be very brief. -14.5. What is the difference between the Revenue generated (in %) in Taxes on income in 2004 and the Revenue generated (in %) in Taxes on international trade in 2005?
Your answer should be very brief. -7.65. What is the average Revenue generated (in %) of Taxes on goods and services per year?
Offer a very short reply. 13.1. What is the average Revenue generated (in %) in Taxes on income per year?
Offer a very short reply. 15.57. What is the average Revenue generated (in %) in Taxes on international trade per year?
Offer a very short reply. 32.03. In the year 1997, what is the difference between the Revenue generated (in %) in Taxes on goods and services and Revenue generated (in %) in Taxes on income?
Offer a terse response. 14.26. In the year 1997, what is the difference between the Revenue generated (in %) in Taxes on goods and services and Revenue generated (in %) in Taxes on international trade?
Your answer should be very brief. -12.24. In the year 1997, what is the difference between the Revenue generated (in %) in Taxes on income and Revenue generated (in %) in Taxes on international trade?
Your answer should be compact. -26.5. In the year 1998, what is the difference between the Revenue generated (in %) of Taxes on goods and services and Revenue generated (in %) of Taxes on income?
Your response must be concise. 6.23. In the year 1998, what is the difference between the Revenue generated (in %) of Taxes on goods and services and Revenue generated (in %) of Taxes on international trade?
Ensure brevity in your answer.  -23.38. In the year 1998, what is the difference between the Revenue generated (in %) in Taxes on income and Revenue generated (in %) in Taxes on international trade?
Your answer should be compact. -29.62. In the year 1999, what is the difference between the Revenue generated (in %) in Taxes on goods and services and Revenue generated (in %) in Taxes on income?
Give a very brief answer. -6.12. In the year 1999, what is the difference between the Revenue generated (in %) of Taxes on goods and services and Revenue generated (in %) of Taxes on international trade?
Provide a short and direct response. -18.57. In the year 1999, what is the difference between the Revenue generated (in %) in Taxes on income and Revenue generated (in %) in Taxes on international trade?
Your answer should be very brief. -12.45. In the year 2000, what is the difference between the Revenue generated (in %) in Taxes on goods and services and Revenue generated (in %) in Taxes on income?
Offer a very short reply. -7.83. In the year 2000, what is the difference between the Revenue generated (in %) of Taxes on goods and services and Revenue generated (in %) of Taxes on international trade?
Provide a short and direct response. -21.84. In the year 2000, what is the difference between the Revenue generated (in %) in Taxes on income and Revenue generated (in %) in Taxes on international trade?
Give a very brief answer. -14.01. In the year 2001, what is the difference between the Revenue generated (in %) of Taxes on goods and services and Revenue generated (in %) of Taxes on income?
Your answer should be very brief. -7.02. In the year 2001, what is the difference between the Revenue generated (in %) of Taxes on goods and services and Revenue generated (in %) of Taxes on international trade?
Your answer should be compact. -24.03. In the year 2001, what is the difference between the Revenue generated (in %) in Taxes on income and Revenue generated (in %) in Taxes on international trade?
Your answer should be very brief. -17.01. In the year 2002, what is the difference between the Revenue generated (in %) in Taxes on goods and services and Revenue generated (in %) in Taxes on income?
Make the answer very short. -5.75. In the year 2002, what is the difference between the Revenue generated (in %) in Taxes on goods and services and Revenue generated (in %) in Taxes on international trade?
Provide a succinct answer. -20.2. In the year 2002, what is the difference between the Revenue generated (in %) in Taxes on income and Revenue generated (in %) in Taxes on international trade?
Offer a very short reply. -14.45. In the year 2003, what is the difference between the Revenue generated (in %) in Taxes on goods and services and Revenue generated (in %) in Taxes on income?
Offer a very short reply. -5.86. In the year 2003, what is the difference between the Revenue generated (in %) of Taxes on goods and services and Revenue generated (in %) of Taxes on international trade?
Your answer should be compact. -20.55. In the year 2003, what is the difference between the Revenue generated (in %) in Taxes on income and Revenue generated (in %) in Taxes on international trade?
Offer a very short reply. -14.69. In the year 2004, what is the difference between the Revenue generated (in %) in Taxes on goods and services and Revenue generated (in %) in Taxes on income?
Provide a succinct answer. -6.85. In the year 2004, what is the difference between the Revenue generated (in %) in Taxes on goods and services and Revenue generated (in %) in Taxes on international trade?
Offer a terse response. -17.96. In the year 2004, what is the difference between the Revenue generated (in %) of Taxes on income and Revenue generated (in %) of Taxes on international trade?
Your answer should be compact. -11.11. In the year 2005, what is the difference between the Revenue generated (in %) in Taxes on goods and services and Revenue generated (in %) in Taxes on income?
Make the answer very short. -3.25. In the year 2005, what is the difference between the Revenue generated (in %) in Taxes on goods and services and Revenue generated (in %) in Taxes on international trade?
Provide a succinct answer. -11.61. In the year 2005, what is the difference between the Revenue generated (in %) in Taxes on income and Revenue generated (in %) in Taxes on international trade?
Keep it short and to the point. -8.36. What is the ratio of the Revenue generated (in %) in Taxes on goods and services in 1997 to that in 1998?
Give a very brief answer. 1.51. What is the ratio of the Revenue generated (in %) of Taxes on income in 1997 to that in 1998?
Your answer should be very brief. 1.15. What is the ratio of the Revenue generated (in %) in Taxes on international trade in 1997 to that in 1998?
Your answer should be very brief. 0.97. What is the ratio of the Revenue generated (in %) in Taxes on goods and services in 1997 to that in 1999?
Make the answer very short. 3.47. What is the ratio of the Revenue generated (in %) of Taxes on income in 1997 to that in 1999?
Ensure brevity in your answer.  1.05. What is the ratio of the Revenue generated (in %) of Taxes on international trade in 1997 to that in 1999?
Your response must be concise. 1.54. What is the ratio of the Revenue generated (in %) of Taxes on goods and services in 1997 to that in 2000?
Your response must be concise. 3.92. What is the ratio of the Revenue generated (in %) in Taxes on international trade in 1997 to that in 2000?
Ensure brevity in your answer.  1.42. What is the ratio of the Revenue generated (in %) of Taxes on goods and services in 1997 to that in 2001?
Ensure brevity in your answer.  2.59. What is the ratio of the Revenue generated (in %) of Taxes on income in 1997 to that in 2001?
Provide a succinct answer. 0.83. What is the ratio of the Revenue generated (in %) of Taxes on international trade in 1997 to that in 2001?
Offer a terse response. 1.18. What is the ratio of the Revenue generated (in %) in Taxes on goods and services in 1997 to that in 2002?
Provide a short and direct response. 2.97. What is the ratio of the Revenue generated (in %) of Taxes on income in 1997 to that in 2002?
Offer a very short reply. 0.98. What is the ratio of the Revenue generated (in %) of Taxes on international trade in 1997 to that in 2002?
Provide a succinct answer. 1.39. What is the ratio of the Revenue generated (in %) of Taxes on goods and services in 1997 to that in 2003?
Your answer should be compact. 2.87. What is the ratio of the Revenue generated (in %) in Taxes on income in 1997 to that in 2003?
Offer a very short reply. 0.95. What is the ratio of the Revenue generated (in %) of Taxes on international trade in 1997 to that in 2003?
Ensure brevity in your answer.  1.36. What is the ratio of the Revenue generated (in %) of Taxes on goods and services in 1997 to that in 2004?
Provide a succinct answer. 3.29. What is the ratio of the Revenue generated (in %) in Taxes on income in 1997 to that in 2004?
Your response must be concise. 0.97. What is the ratio of the Revenue generated (in %) of Taxes on international trade in 1997 to that in 2004?
Make the answer very short. 1.55. What is the ratio of the Revenue generated (in %) of Taxes on goods and services in 1997 to that in 2005?
Ensure brevity in your answer.  2.49. What is the ratio of the Revenue generated (in %) of Taxes on income in 1997 to that in 2005?
Your answer should be very brief. 1.01. What is the ratio of the Revenue generated (in %) of Taxes on international trade in 1997 to that in 2005?
Provide a short and direct response. 1.78. What is the ratio of the Revenue generated (in %) in Taxes on goods and services in 1998 to that in 1999?
Give a very brief answer. 2.3. What is the ratio of the Revenue generated (in %) in Taxes on income in 1998 to that in 1999?
Offer a terse response. 0.91. What is the ratio of the Revenue generated (in %) in Taxes on international trade in 1998 to that in 1999?
Offer a terse response. 1.59. What is the ratio of the Revenue generated (in %) in Taxes on goods and services in 1998 to that in 2000?
Your answer should be compact. 2.6. What is the ratio of the Revenue generated (in %) in Taxes on income in 1998 to that in 2000?
Ensure brevity in your answer.  0.87. What is the ratio of the Revenue generated (in %) in Taxes on international trade in 1998 to that in 2000?
Your answer should be very brief. 1.46. What is the ratio of the Revenue generated (in %) in Taxes on goods and services in 1998 to that in 2001?
Provide a short and direct response. 1.71. What is the ratio of the Revenue generated (in %) in Taxes on income in 1998 to that in 2001?
Provide a short and direct response. 0.72. What is the ratio of the Revenue generated (in %) in Taxes on international trade in 1998 to that in 2001?
Your answer should be very brief. 1.21. What is the ratio of the Revenue generated (in %) of Taxes on goods and services in 1998 to that in 2002?
Provide a short and direct response. 1.97. What is the ratio of the Revenue generated (in %) in Taxes on income in 1998 to that in 2002?
Ensure brevity in your answer.  0.85. What is the ratio of the Revenue generated (in %) of Taxes on international trade in 1998 to that in 2002?
Your response must be concise. 1.42. What is the ratio of the Revenue generated (in %) in Taxes on goods and services in 1998 to that in 2003?
Your answer should be compact. 1.9. What is the ratio of the Revenue generated (in %) in Taxes on income in 1998 to that in 2003?
Your response must be concise. 0.83. What is the ratio of the Revenue generated (in %) of Taxes on international trade in 1998 to that in 2003?
Give a very brief answer. 1.39. What is the ratio of the Revenue generated (in %) in Taxes on goods and services in 1998 to that in 2004?
Provide a succinct answer. 2.18. What is the ratio of the Revenue generated (in %) of Taxes on income in 1998 to that in 2004?
Your answer should be compact. 0.84. What is the ratio of the Revenue generated (in %) of Taxes on international trade in 1998 to that in 2004?
Give a very brief answer. 1.59. What is the ratio of the Revenue generated (in %) in Taxes on goods and services in 1998 to that in 2005?
Your answer should be very brief. 1.65. What is the ratio of the Revenue generated (in %) in Taxes on income in 1998 to that in 2005?
Make the answer very short. 0.88. What is the ratio of the Revenue generated (in %) of Taxes on international trade in 1998 to that in 2005?
Offer a very short reply. 1.83. What is the ratio of the Revenue generated (in %) in Taxes on goods and services in 1999 to that in 2000?
Make the answer very short. 1.13. What is the ratio of the Revenue generated (in %) of Taxes on income in 1999 to that in 2000?
Ensure brevity in your answer.  0.95. What is the ratio of the Revenue generated (in %) in Taxes on international trade in 1999 to that in 2000?
Ensure brevity in your answer.  0.92. What is the ratio of the Revenue generated (in %) of Taxes on goods and services in 1999 to that in 2001?
Give a very brief answer. 0.75. What is the ratio of the Revenue generated (in %) of Taxes on income in 1999 to that in 2001?
Provide a succinct answer. 0.79. What is the ratio of the Revenue generated (in %) in Taxes on international trade in 1999 to that in 2001?
Ensure brevity in your answer.  0.76. What is the ratio of the Revenue generated (in %) in Taxes on goods and services in 1999 to that in 2002?
Your response must be concise. 0.86. What is the ratio of the Revenue generated (in %) in Taxes on income in 1999 to that in 2002?
Offer a terse response. 0.93. What is the ratio of the Revenue generated (in %) of Taxes on international trade in 1999 to that in 2002?
Give a very brief answer. 0.9. What is the ratio of the Revenue generated (in %) in Taxes on goods and services in 1999 to that in 2003?
Your answer should be compact. 0.83. What is the ratio of the Revenue generated (in %) of Taxes on income in 1999 to that in 2003?
Make the answer very short. 0.9. What is the ratio of the Revenue generated (in %) in Taxes on international trade in 1999 to that in 2003?
Ensure brevity in your answer.  0.88. What is the ratio of the Revenue generated (in %) in Taxes on goods and services in 1999 to that in 2004?
Your answer should be very brief. 0.95. What is the ratio of the Revenue generated (in %) of Taxes on income in 1999 to that in 2004?
Keep it short and to the point. 0.92. What is the ratio of the Revenue generated (in %) in Taxes on international trade in 1999 to that in 2004?
Make the answer very short. 1.01. What is the ratio of the Revenue generated (in %) in Taxes on goods and services in 1999 to that in 2005?
Give a very brief answer. 0.72. What is the ratio of the Revenue generated (in %) of Taxes on income in 1999 to that in 2005?
Offer a very short reply. 0.97. What is the ratio of the Revenue generated (in %) of Taxes on international trade in 1999 to that in 2005?
Provide a short and direct response. 1.15. What is the ratio of the Revenue generated (in %) of Taxes on goods and services in 2000 to that in 2001?
Ensure brevity in your answer.  0.66. What is the ratio of the Revenue generated (in %) in Taxes on income in 2000 to that in 2001?
Make the answer very short. 0.83. What is the ratio of the Revenue generated (in %) of Taxes on international trade in 2000 to that in 2001?
Make the answer very short. 0.83. What is the ratio of the Revenue generated (in %) of Taxes on goods and services in 2000 to that in 2002?
Ensure brevity in your answer.  0.76. What is the ratio of the Revenue generated (in %) of Taxes on income in 2000 to that in 2002?
Offer a very short reply. 0.98. What is the ratio of the Revenue generated (in %) of Taxes on international trade in 2000 to that in 2002?
Ensure brevity in your answer.  0.97. What is the ratio of the Revenue generated (in %) in Taxes on goods and services in 2000 to that in 2003?
Your answer should be compact. 0.73. What is the ratio of the Revenue generated (in %) of Taxes on income in 2000 to that in 2003?
Ensure brevity in your answer.  0.95. What is the ratio of the Revenue generated (in %) of Taxes on international trade in 2000 to that in 2003?
Offer a very short reply. 0.95. What is the ratio of the Revenue generated (in %) in Taxes on goods and services in 2000 to that in 2004?
Ensure brevity in your answer.  0.84. What is the ratio of the Revenue generated (in %) of Taxes on income in 2000 to that in 2004?
Offer a very short reply. 0.97. What is the ratio of the Revenue generated (in %) of Taxes on international trade in 2000 to that in 2004?
Keep it short and to the point. 1.09. What is the ratio of the Revenue generated (in %) in Taxes on goods and services in 2000 to that in 2005?
Make the answer very short. 0.64. What is the ratio of the Revenue generated (in %) of Taxes on income in 2000 to that in 2005?
Make the answer very short. 1.02. What is the ratio of the Revenue generated (in %) of Taxes on international trade in 2000 to that in 2005?
Ensure brevity in your answer.  1.25. What is the ratio of the Revenue generated (in %) in Taxes on goods and services in 2001 to that in 2002?
Your answer should be compact. 1.15. What is the ratio of the Revenue generated (in %) of Taxes on income in 2001 to that in 2002?
Keep it short and to the point. 1.18. What is the ratio of the Revenue generated (in %) in Taxes on international trade in 2001 to that in 2002?
Offer a terse response. 1.18. What is the ratio of the Revenue generated (in %) in Taxes on goods and services in 2001 to that in 2003?
Offer a terse response. 1.11. What is the ratio of the Revenue generated (in %) in Taxes on income in 2001 to that in 2003?
Keep it short and to the point. 1.14. What is the ratio of the Revenue generated (in %) of Taxes on international trade in 2001 to that in 2003?
Provide a short and direct response. 1.15. What is the ratio of the Revenue generated (in %) in Taxes on goods and services in 2001 to that in 2004?
Ensure brevity in your answer.  1.27. What is the ratio of the Revenue generated (in %) of Taxes on income in 2001 to that in 2004?
Offer a terse response. 1.17. What is the ratio of the Revenue generated (in %) of Taxes on international trade in 2001 to that in 2004?
Make the answer very short. 1.32. What is the ratio of the Revenue generated (in %) in Taxes on goods and services in 2001 to that in 2005?
Give a very brief answer. 0.96. What is the ratio of the Revenue generated (in %) in Taxes on income in 2001 to that in 2005?
Keep it short and to the point. 1.22. What is the ratio of the Revenue generated (in %) of Taxes on international trade in 2001 to that in 2005?
Provide a succinct answer. 1.51. What is the ratio of the Revenue generated (in %) of Taxes on goods and services in 2002 to that in 2003?
Make the answer very short. 0.97. What is the ratio of the Revenue generated (in %) of Taxes on income in 2002 to that in 2003?
Your response must be concise. 0.97. What is the ratio of the Revenue generated (in %) of Taxes on international trade in 2002 to that in 2003?
Keep it short and to the point. 0.98. What is the ratio of the Revenue generated (in %) of Taxes on goods and services in 2002 to that in 2004?
Give a very brief answer. 1.11. What is the ratio of the Revenue generated (in %) of Taxes on international trade in 2002 to that in 2004?
Your response must be concise. 1.12. What is the ratio of the Revenue generated (in %) of Taxes on goods and services in 2002 to that in 2005?
Your answer should be compact. 0.84. What is the ratio of the Revenue generated (in %) in Taxes on income in 2002 to that in 2005?
Provide a short and direct response. 1.04. What is the ratio of the Revenue generated (in %) in Taxes on international trade in 2002 to that in 2005?
Your answer should be compact. 1.28. What is the ratio of the Revenue generated (in %) of Taxes on goods and services in 2003 to that in 2004?
Provide a short and direct response. 1.15. What is the ratio of the Revenue generated (in %) of Taxes on income in 2003 to that in 2004?
Ensure brevity in your answer.  1.02. What is the ratio of the Revenue generated (in %) in Taxes on international trade in 2003 to that in 2004?
Offer a very short reply. 1.15. What is the ratio of the Revenue generated (in %) of Taxes on goods and services in 2003 to that in 2005?
Give a very brief answer. 0.87. What is the ratio of the Revenue generated (in %) of Taxes on income in 2003 to that in 2005?
Provide a succinct answer. 1.07. What is the ratio of the Revenue generated (in %) in Taxes on international trade in 2003 to that in 2005?
Make the answer very short. 1.31. What is the ratio of the Revenue generated (in %) of Taxes on goods and services in 2004 to that in 2005?
Offer a terse response. 0.76. What is the ratio of the Revenue generated (in %) in Taxes on income in 2004 to that in 2005?
Make the answer very short. 1.05. What is the ratio of the Revenue generated (in %) in Taxes on international trade in 2004 to that in 2005?
Your answer should be compact. 1.15. What is the difference between the highest and the second highest Revenue generated (in %) in Taxes on goods and services?
Your answer should be compact. 9.99. What is the difference between the highest and the second highest Revenue generated (in %) in Taxes on income?
Ensure brevity in your answer.  2.29. What is the difference between the highest and the second highest Revenue generated (in %) in Taxes on international trade?
Give a very brief answer. 1.15. What is the difference between the highest and the lowest Revenue generated (in %) of Taxes on goods and services?
Make the answer very short. 22.04. What is the difference between the highest and the lowest Revenue generated (in %) of Taxes on income?
Your answer should be very brief. 5.1. What is the difference between the highest and the lowest Revenue generated (in %) in Taxes on international trade?
Your response must be concise. 19.49. 